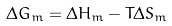Convert formula to latex. <formula><loc_0><loc_0><loc_500><loc_500>\Delta G _ { m } = \Delta H _ { m } - T \Delta S _ { m }</formula> 